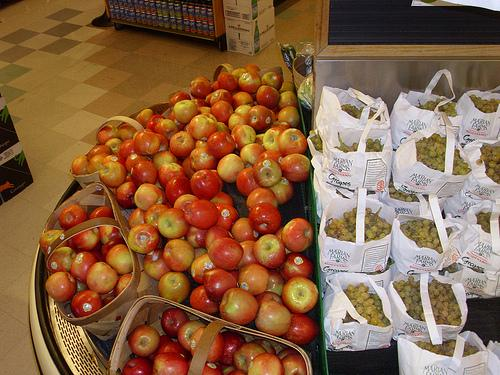Tell us about the presence of fruits apart from apples and grapes. The image only features apples and grapes as displayed fruits, with no other fruits present in the scene. Mention the flooring pattern and any notable items on the floor. Square multi-colored tiles cover the floor, with white boxes and stacks of sparkling water near the apple display. Explain the surface design of the floor in the image. The floor in the image has checkered, multi-colored square tiles with various hues, creating a vibrant pattern. Describe any signage or text visible in the image. There is a black display board above the grapes section, but no visible text or specific signage can be discerned. Identify any unique features of the apples in the image. The apples in the image have produce stickers on them, indicating their origin or brand. Provide a brief description of the major elements in the image. The image features a produce display with apples and grapes, wooden baskets, white bags, stacks of boxes, square tiles on the floor, and various other details. Provide an overview of the image by mentioning the main components and their arrangement. The image displays a grocery store scene with apples in wooden baskets and grapes in white bags on a table, separated by a green divider, surrounded by square-tiled flooring and stacks of boxes. Describe at least three different produce items showcased in the image. The image showcases yellow and red apples in wooden baskets, green grapes in white bags, and a wine bottle on a box of sparkling water. Describe the main types of containers used to hold the fruits in the image. The main types of containers used to hold the fruits in the image are wooden baskets for apples and white bags for green grapes. Mention the central items displayed in the image and their arrangement. Apples and grapes are the central items in the image, displayed on a table with apples in wooden baskets and grapes in white bags separated by a green divider. 